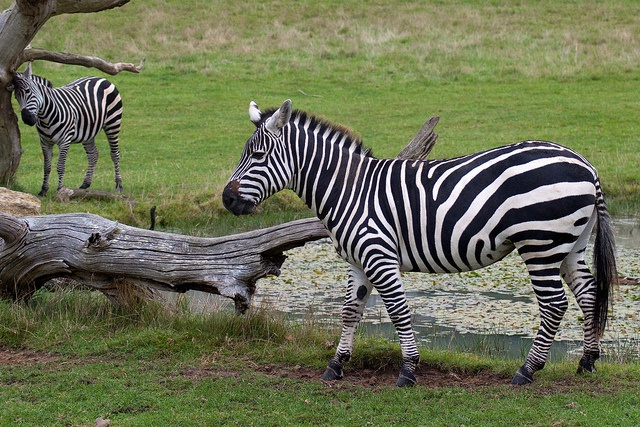Describe the objects in this image and their specific colors. I can see zebra in olive, black, lightgray, gray, and darkgray tones and zebra in olive, black, gray, darkgray, and lavender tones in this image. 